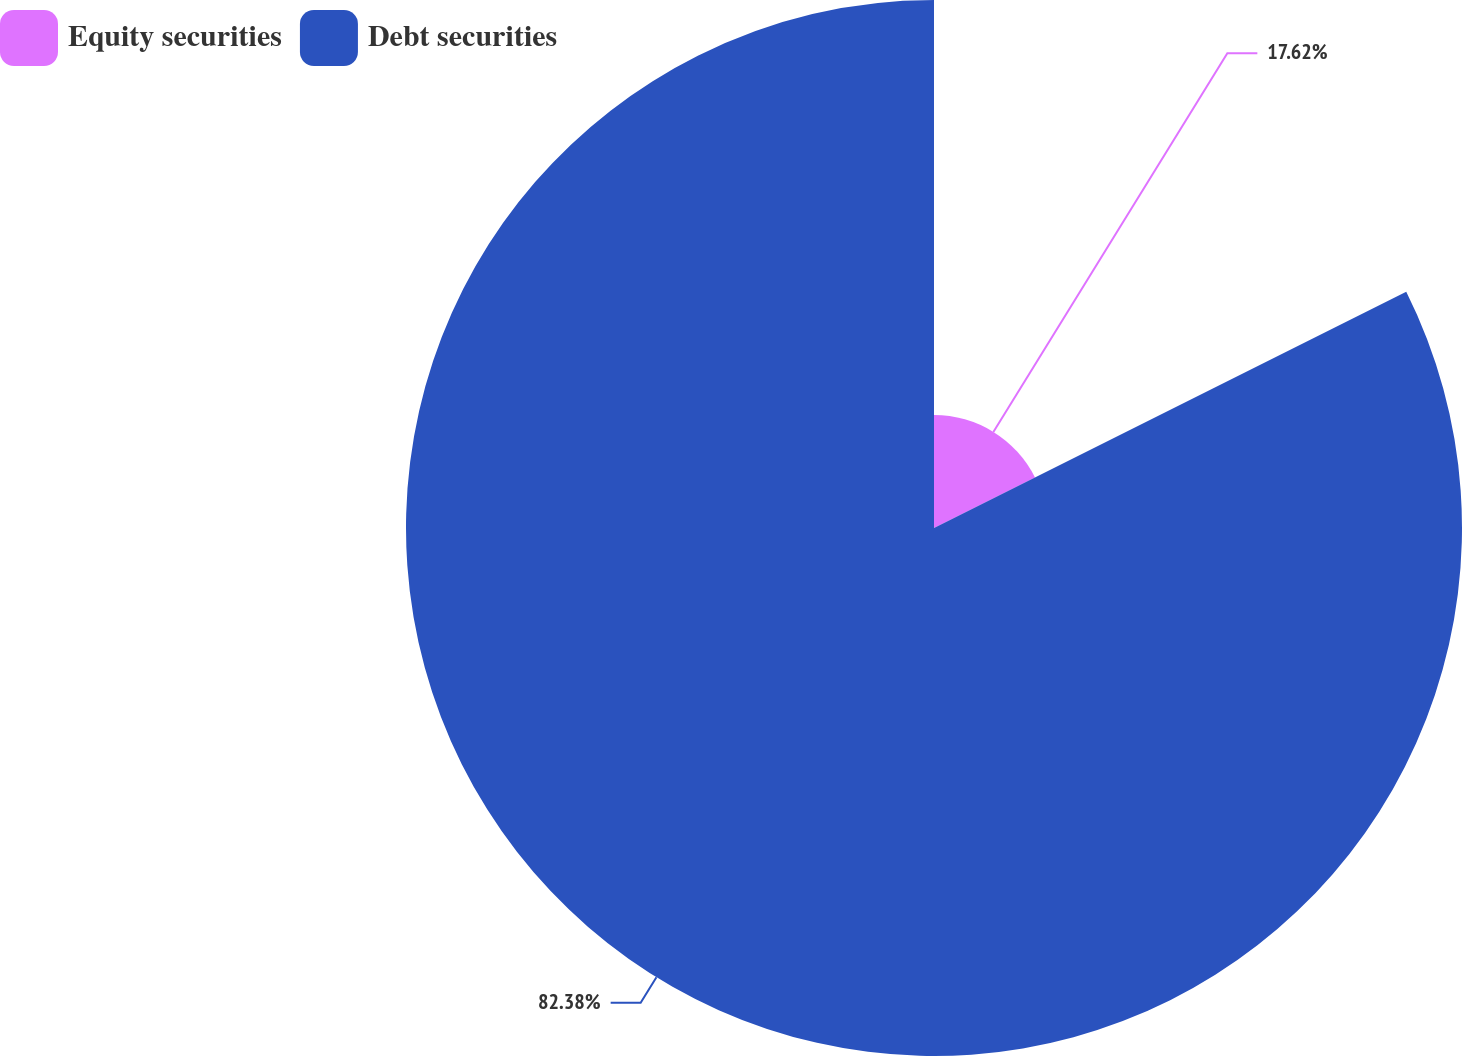<chart> <loc_0><loc_0><loc_500><loc_500><pie_chart><fcel>Equity securities<fcel>Debt securities<nl><fcel>17.62%<fcel>82.38%<nl></chart> 